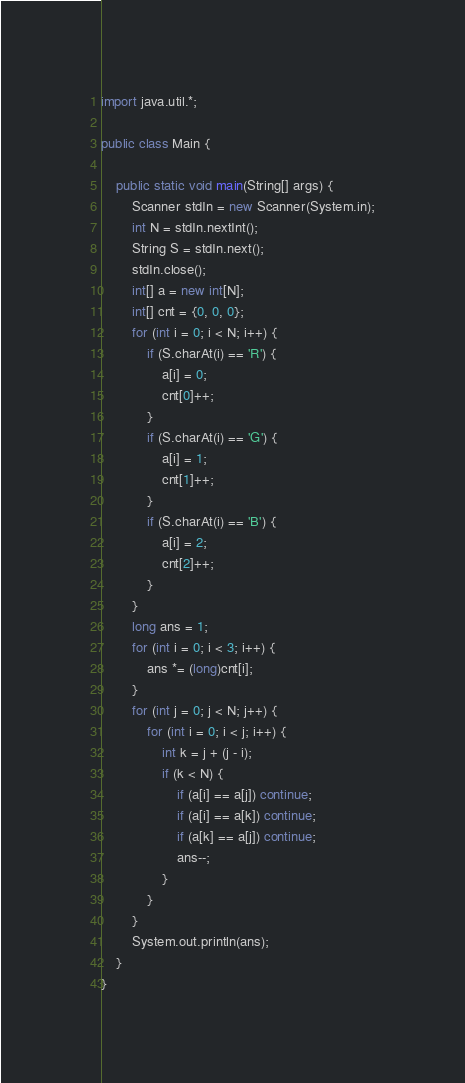<code> <loc_0><loc_0><loc_500><loc_500><_Java_>import java.util.*;
 
public class Main {
 
    public static void main(String[] args) {
        Scanner stdIn = new Scanner(System.in);
        int N = stdIn.nextInt();    
        String S = stdIn.next();
        stdIn.close();
        int[] a = new int[N];
        int[] cnt = {0, 0, 0};
        for (int i = 0; i < N; i++) {
            if (S.charAt(i) == 'R') {
                a[i] = 0;
                cnt[0]++;
            }
            if (S.charAt(i) == 'G') {
                a[i] = 1;
                cnt[1]++;
            }
            if (S.charAt(i) == 'B') {
                a[i] = 2;
                cnt[2]++;
            }
        }
        long ans = 1;
        for (int i = 0; i < 3; i++) {
            ans *= (long)cnt[i];
        }
        for (int j = 0; j < N; j++) {
            for (int i = 0; i < j; i++) {
                int k = j + (j - i);
                if (k < N) {
                    if (a[i] == a[j]) continue;
                    if (a[i] == a[k]) continue;
                    if (a[k] == a[j]) continue;
                    ans--;
                }
            }
        }
        System.out.println(ans);        
    }
}</code> 